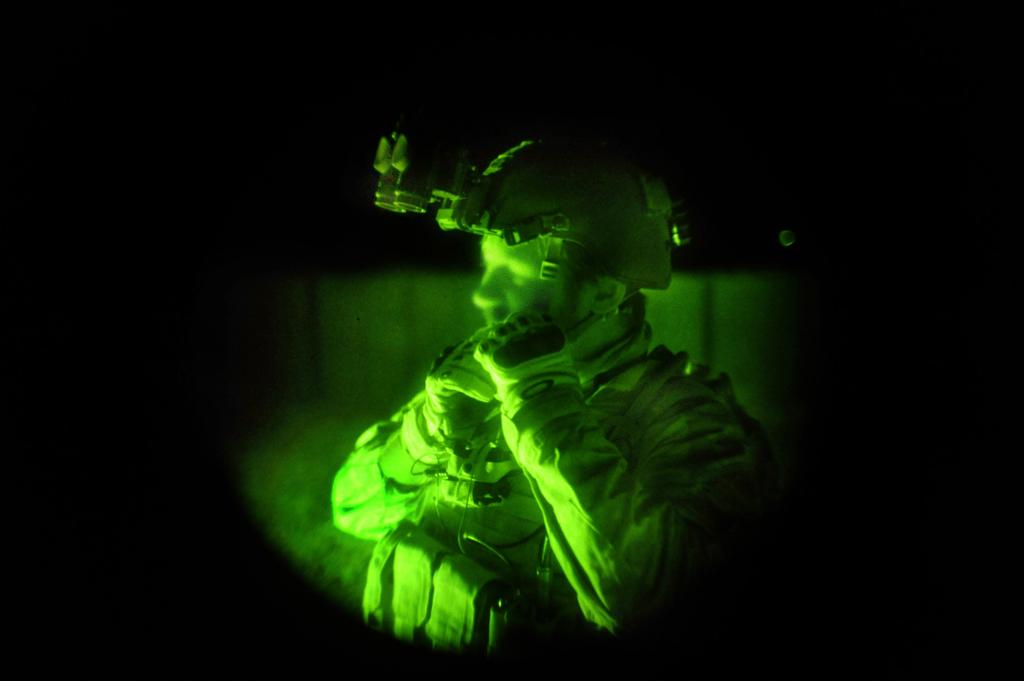What is present in the image? There is a person in the image. Can you describe the person's attire? The person is wearing clothes and a helmet. What type of alarm can be heard in the image? There is no alarm present in the image; it is a still image with no sound. 